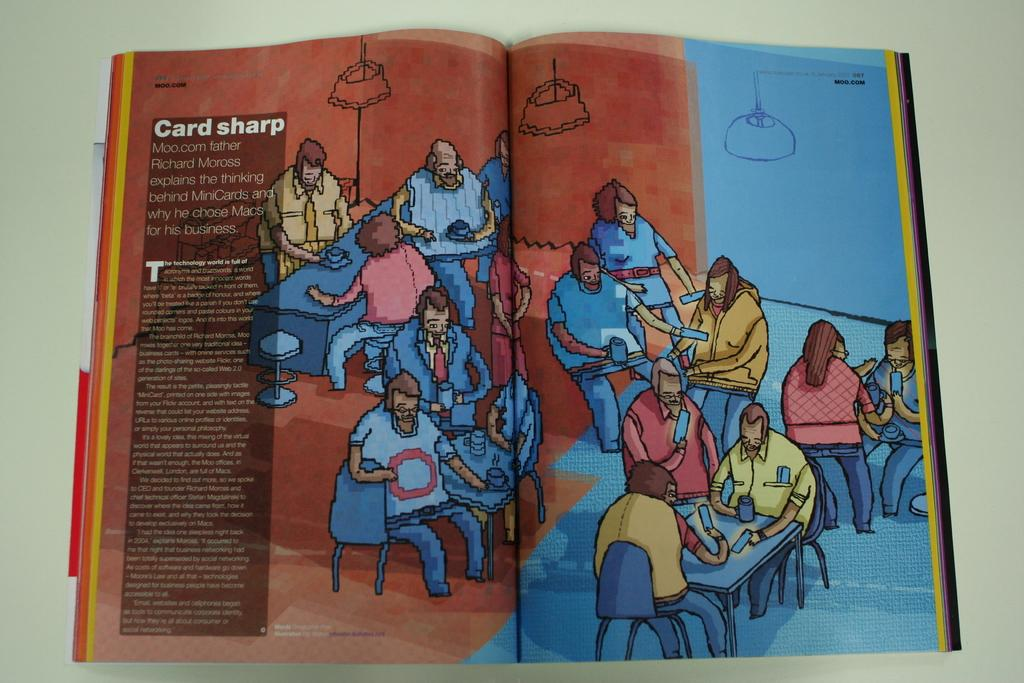<image>
Share a concise interpretation of the image provided. A technology article featuring the thoughts of Richard Moross. 